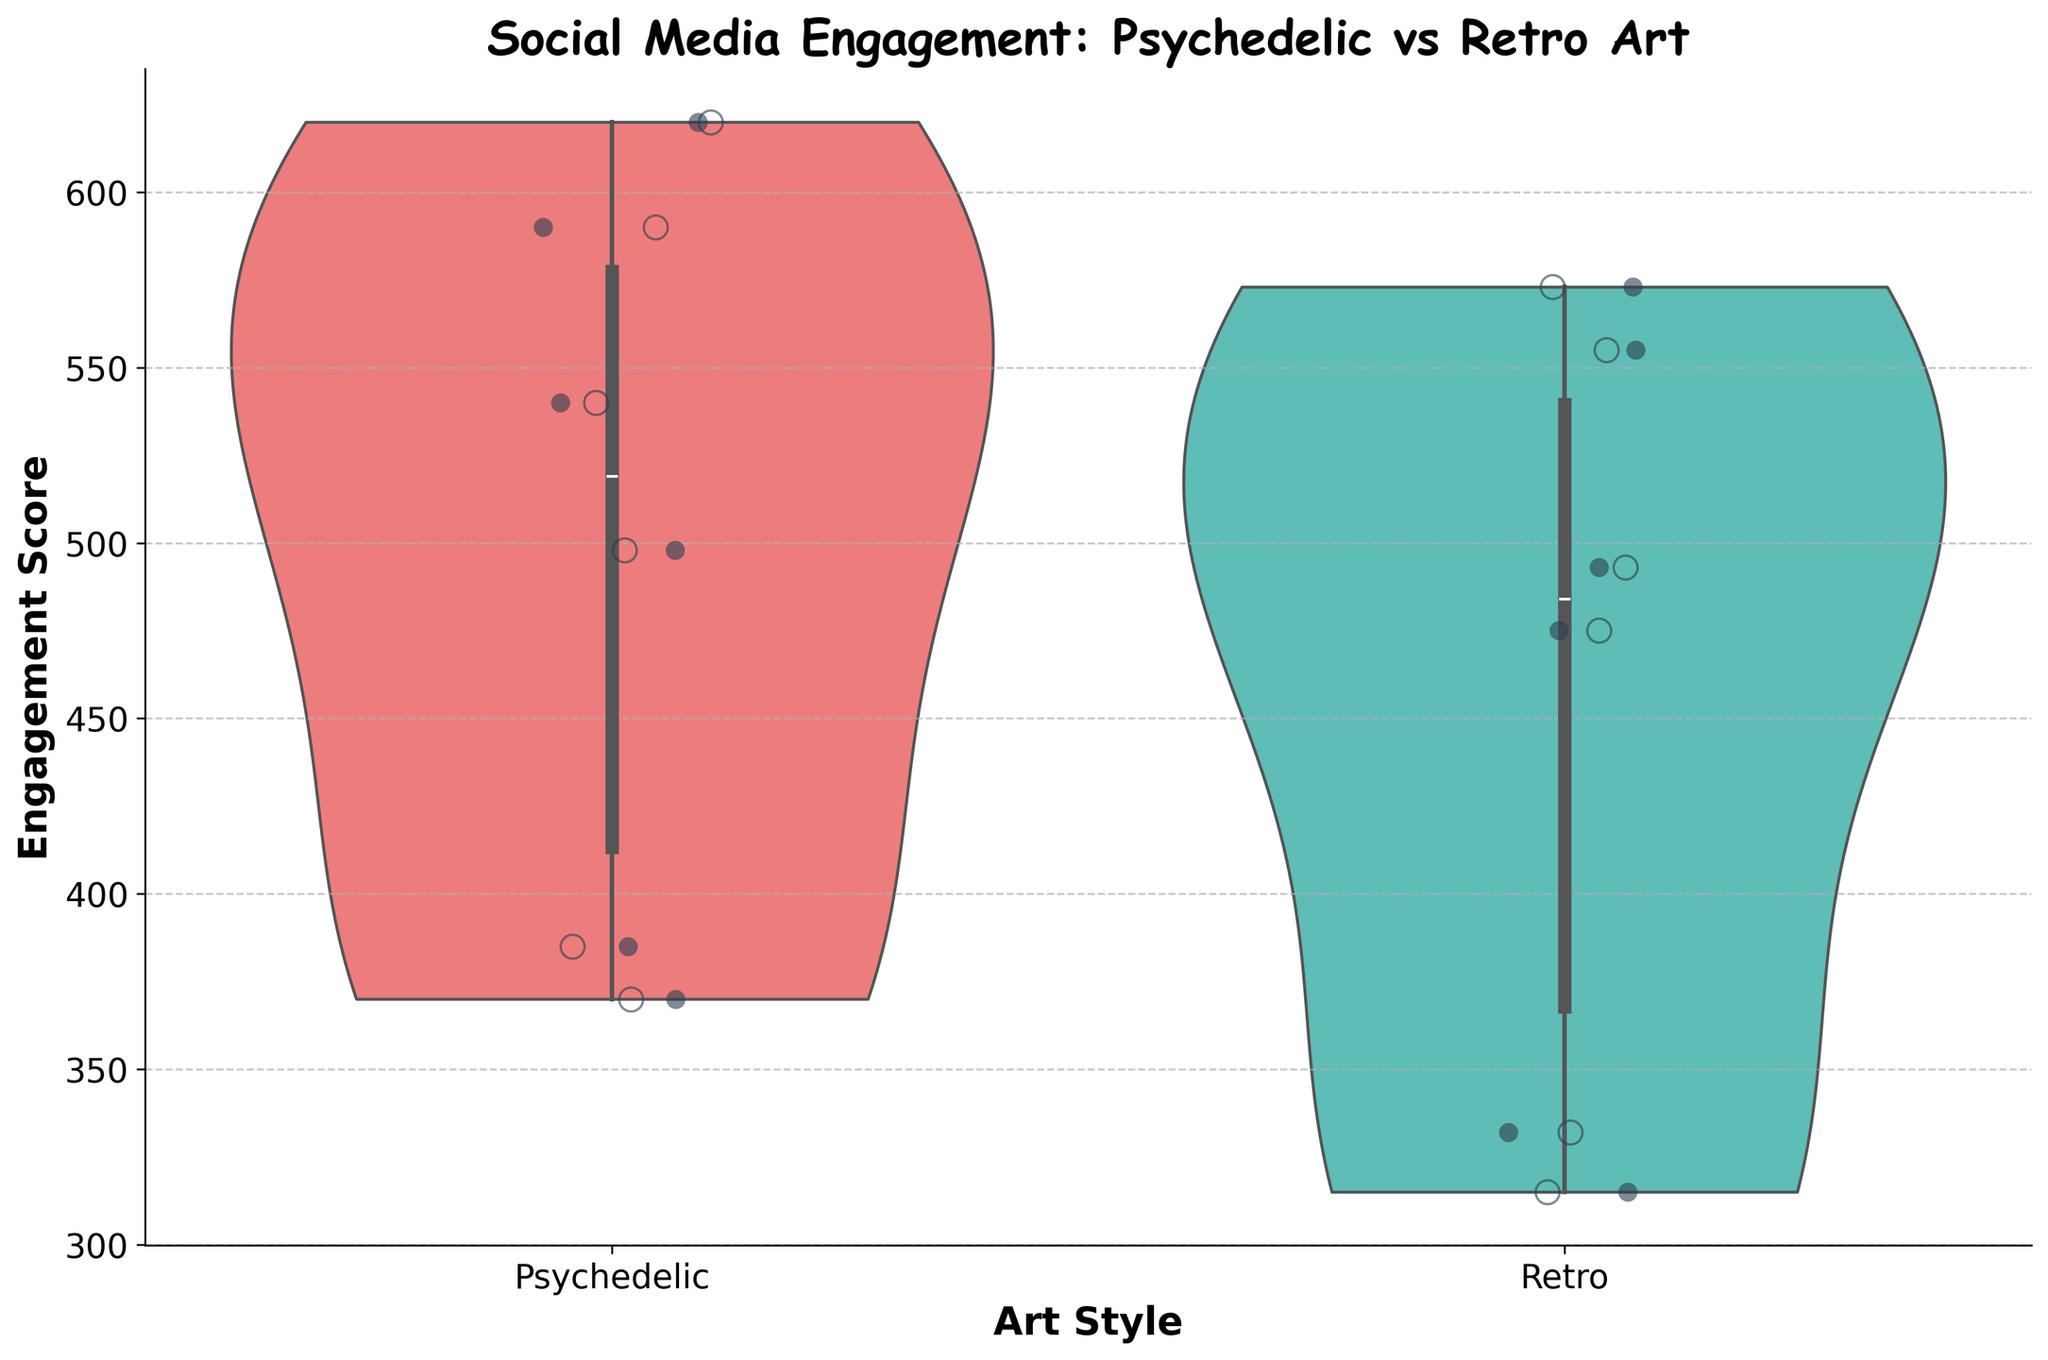What's the title of the plot? The title of the plot is usually displayed at the top of the figure. In this case, it reads "Social Media Engagement: Psychedelic vs Retro Art".
Answer: Social Media Engagement: Psychedelic vs Retro Art What are the X and Y axis labels? X-axis labels often describe the categories being compared, and Y-axis labels describe the measured values. Here, the X-axis is labeled "Art Style" and the Y-axis is labeled "Engagement Score".
Answer: X: Art Style, Y: Engagement Score Which art style shows a higher maximum engagement score? By examining the topmost points on the Y-axis for both "Psychedelic" and "Retro" categories, the "Psychedelic" category reaches higher towards the top of the plot.
Answer: Psychedelic Are the engagement scores for Psychedelic art style more spread out or less spread out compared to Retro art style? To determine the spread, one needs to observe how wide the violin plots are. The "Psychedelic" violin plot appears wider than the "Retro" violin plot, indicating more spread out engagement scores.
Answer: More spread out How many jittered points are shown for each art style? Count the individual points that are superimposed on the violin plots. Both "Psychedelic" and "Retro" have six points each.
Answer: Six What's the average engagement score for the "Retro" art style? Compute the average by summing up all engagement scores for "Retro" (555 + 315 + 475 + 573 + 332 + 493) and dividing by the number of observations (6). Calculating this: (555 + 315 + 475 + 573 + 332 + 493) / 6 = 2743 / 6 = 457.1667.
Answer: 457.17 Is there any overlap in the engagement scores between the Psychedelic and Retro art styles? Overlap can be determined by looking at the areas where both violin plots extend along the Y-axis. Both have engagement scores ranging approximately from 300 to 620, indicating overlap.
Answer: Yes How does the median engagement score for Psychedelic compare to Retro? The median is typically indicated by the central bar within the box of the violin plot. The median engagement score for Psychedelic is slightly higher than that for Retro because the bar in the Psychedelic plot sits higher on the Y-axis.
Answer: Psychedelic is higher Do both art styles have outliers? Outliers are often represented by individual points that fall outside the main shape of the violin plot. While exact outliers are not easily identified here, the plot does show jittered points to help understand overall spread. Based on visual inspection, neither style has extreme outliers.
Answer: No clear outliers 